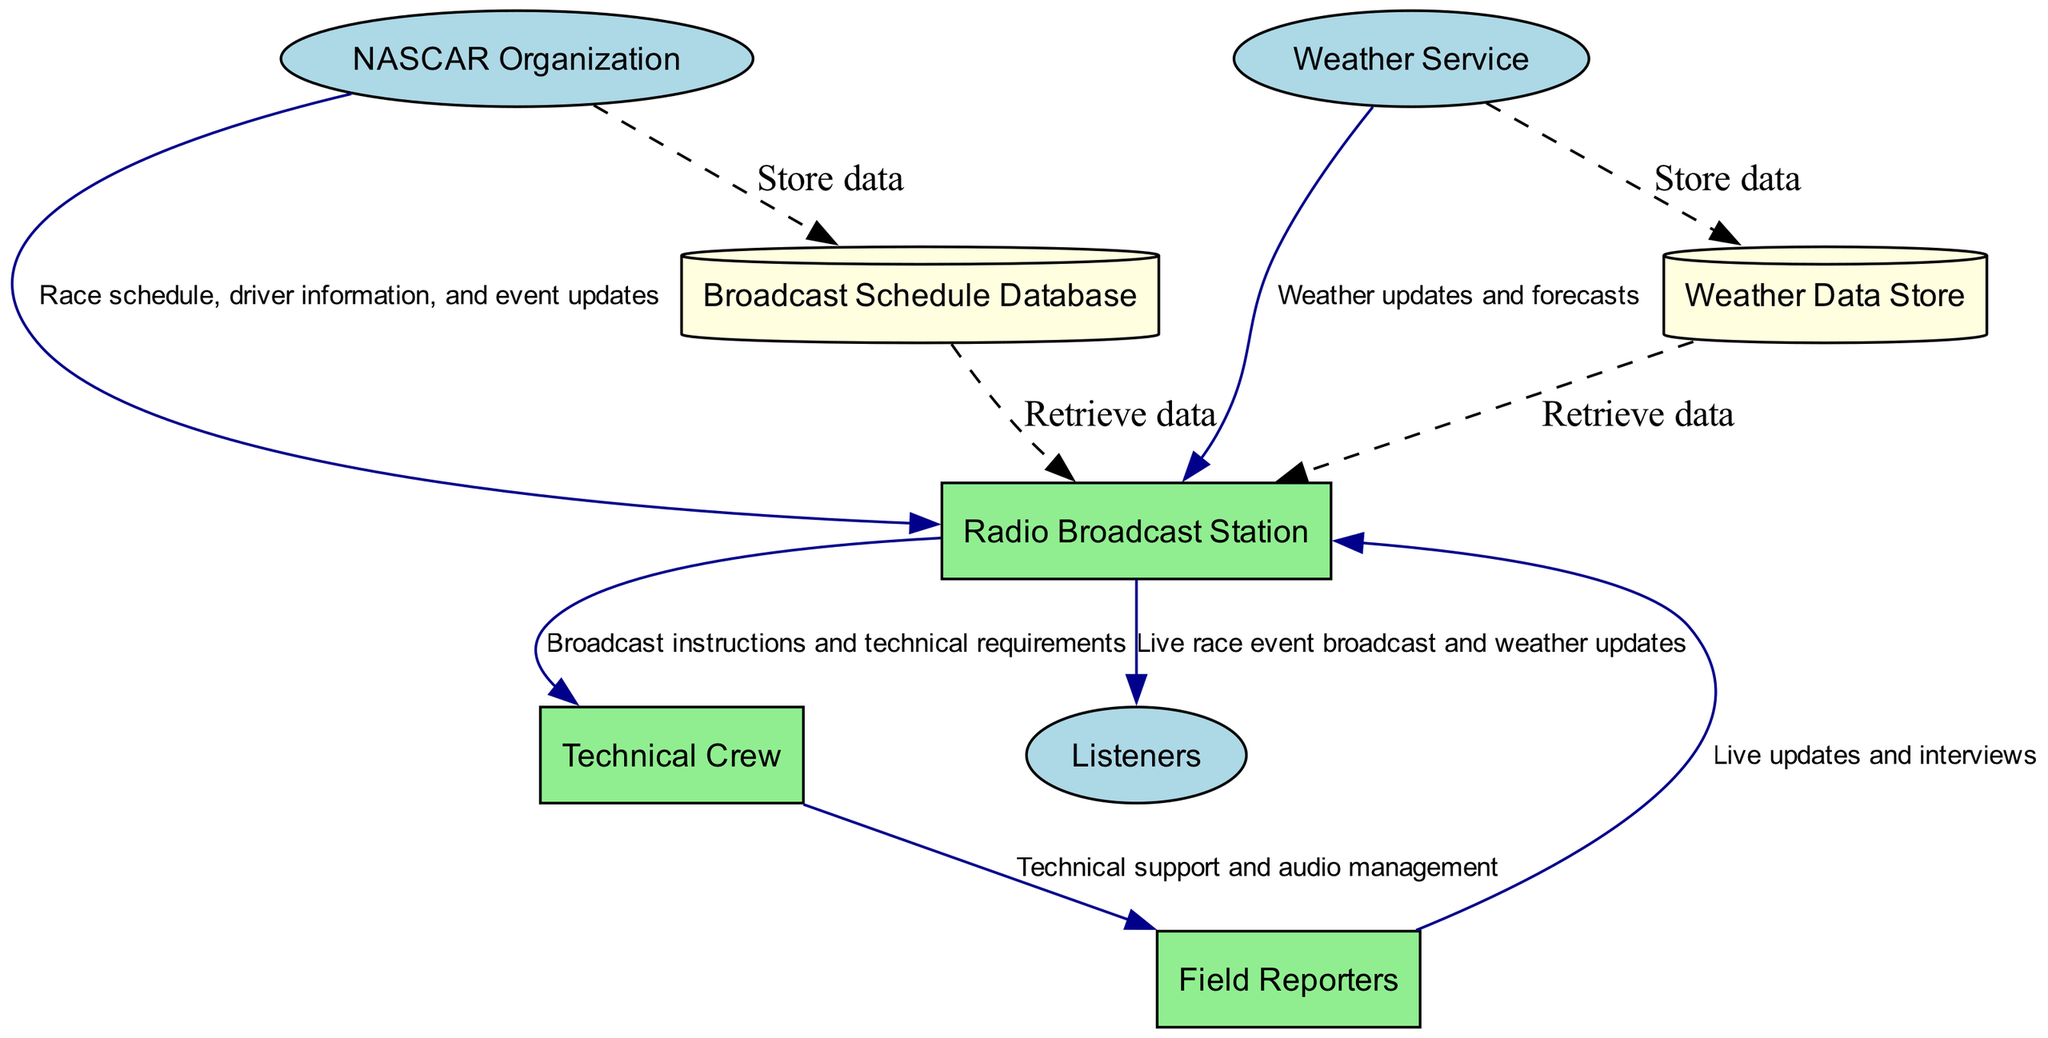What is the main external entity providing race schedule and updates? The diagram indicates that the NASCAR Organization is the main external entity responsible for providing the official race schedule, driver information, and event updates to the Radio Broadcast Station.
Answer: NASCAR Organization How many processes are depicted in the diagram? According to the diagram, there are three processes: Radio Broadcast Station, Field Reporters, and Technical Crew. Counting these yields a total of three processes.
Answer: 3 What type of data does the Weather Service provide? The Weather Service supplies real-time weather updates and forecasts, which flow to the Radio Broadcast Station as indicated in the diagram.
Answer: Weather updates and forecasts Who receives the live updates and interviews from the Field Reporters? The Field Reporters send live updates and interviews to the Radio Broadcast Station, which then utilizes this information for broadcasting to the listeners.
Answer: Radio Broadcast Station Which process is responsible for ensuring the quality of audio? The Technical Crew is explicitly identified in the diagram as the process that ensures the quality of audio and manages the broadcasting equipment.
Answer: Technical Crew What is the main data flow from the NASCAR Organization to the Radio Broadcast Station? The primary data flow from the NASCAR Organization to the Radio Broadcast Station consists of race schedule, driver information, and event updates as labeled in the diagram.
Answer: Race schedule, driver information, and event updates What type of data is stored in the Broadcast Schedule Database? The Broadcast Schedule Database is designed to store race schedules, driver details, and event updates obtained from the NASCAR Organization, as represented in the diagram's description.
Answer: Race schedules, driver details, and event updates What dashed lines indicate in the diagram? The dashed lines represent data storage connections, signifying that the NASCAR Organization and Weather Service store their respective data in dedicated databases. This indicates that data flows into the databases and retrieves information from them.
Answer: Storage connections Where do listeners receive the live race event broadcast? Listeners receive the live race event broadcast directly from the Radio Broadcast Station, which also communicates any weather updates during the event.
Answer: Radio Broadcast Station 